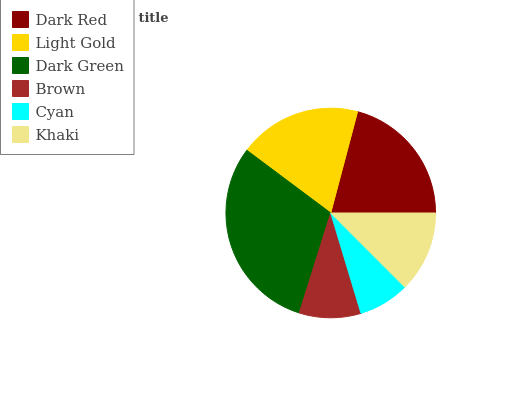Is Cyan the minimum?
Answer yes or no. Yes. Is Dark Green the maximum?
Answer yes or no. Yes. Is Light Gold the minimum?
Answer yes or no. No. Is Light Gold the maximum?
Answer yes or no. No. Is Dark Red greater than Light Gold?
Answer yes or no. Yes. Is Light Gold less than Dark Red?
Answer yes or no. Yes. Is Light Gold greater than Dark Red?
Answer yes or no. No. Is Dark Red less than Light Gold?
Answer yes or no. No. Is Light Gold the high median?
Answer yes or no. Yes. Is Khaki the low median?
Answer yes or no. Yes. Is Brown the high median?
Answer yes or no. No. Is Light Gold the low median?
Answer yes or no. No. 